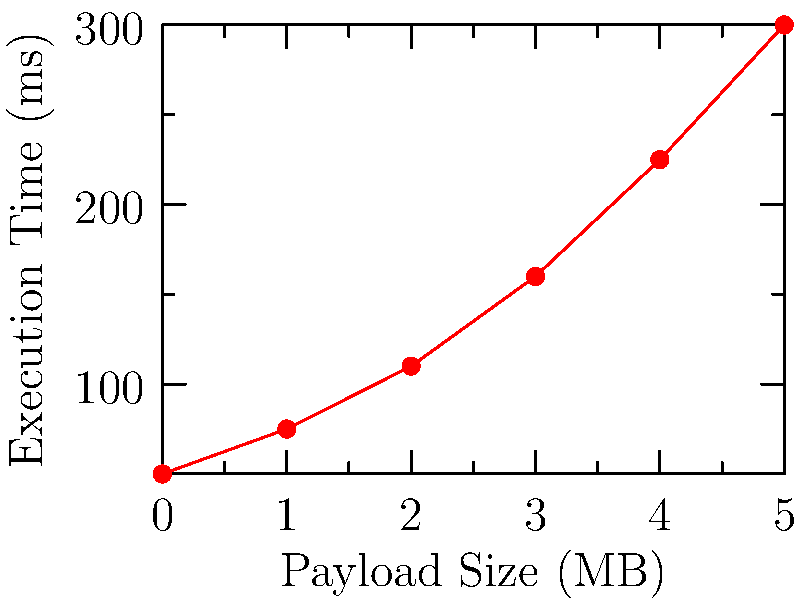Based on the line graph showing Vercel's serverless function execution time with varying payload sizes, what is the approximate execution time for a payload size of 2.5 MB? To determine the approximate execution time for a payload size of 2.5 MB, we need to follow these steps:

1. Observe that the graph shows a non-linear relationship between payload size and execution time.
2. Identify the data points closest to 2.5 MB:
   - At 2 MB, the execution time is approximately 110 ms
   - At 3 MB, the execution time is approximately 160 ms
3. Since 2.5 MB is halfway between 2 MB and 3 MB, we can estimate the execution time by interpolating:
   $$ \text{Estimated time} = 110 \text{ ms} + \frac{160 \text{ ms} - 110 \text{ ms}}{2} = 110 \text{ ms} + 25 \text{ ms} = 135 \text{ ms} $$
4. The graph shows a slight curve, so the actual value might be slightly higher than the linear interpolation.
5. Considering the curve, we can estimate the execution time to be approximately 140 ms for a 2.5 MB payload.
Answer: Approximately 140 ms 